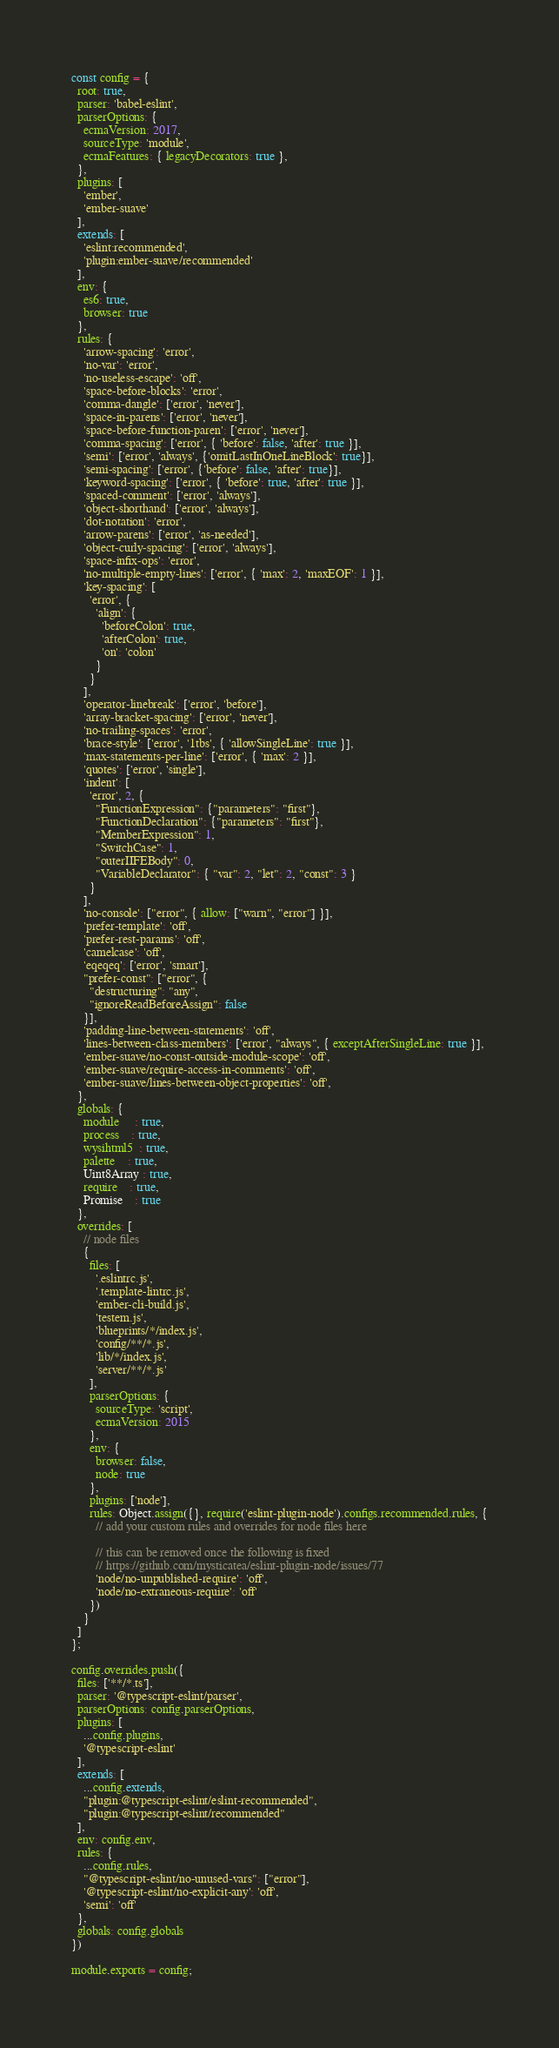<code> <loc_0><loc_0><loc_500><loc_500><_JavaScript_>const config = {
  root: true,
  parser: 'babel-eslint',
  parserOptions: {
    ecmaVersion: 2017,
    sourceType: 'module',
    ecmaFeatures: { legacyDecorators: true },
  },
  plugins: [
    'ember',
    'ember-suave'
  ],
  extends: [
    'eslint:recommended',
    'plugin:ember-suave/recommended'
  ],
  env: {
    es6: true,
    browser: true
  },
  rules: {
    'arrow-spacing': 'error',
    'no-var': 'error',
    'no-useless-escape': 'off',
    'space-before-blocks': 'error',
    'comma-dangle': ['error', 'never'],
    'space-in-parens': ['error', 'never'],
    'space-before-function-paren': ['error', 'never'],
    'comma-spacing': ['error', { 'before': false, 'after': true }],
    'semi': ['error', 'always', {'omitLastInOneLineBlock': true}],
    'semi-spacing': ['error', {'before': false, 'after': true}],
    'keyword-spacing': ['error', { 'before': true, 'after': true }],
    'spaced-comment': ['error', 'always'],
    'object-shorthand': ['error', 'always'],
    'dot-notation': 'error',
    'arrow-parens': ['error', 'as-needed'],
    'object-curly-spacing': ['error', 'always'],
    'space-infix-ops': 'error',
    'no-multiple-empty-lines': ['error', { 'max': 2, 'maxEOF': 1 }],
    'key-spacing': [
      'error', {
        'align': {
          'beforeColon': true,
          'afterColon': true,
          'on': 'colon'
        }
      }
    ],
    'operator-linebreak': ['error', 'before'],
    'array-bracket-spacing': ['error', 'never'],
    'no-trailing-spaces': 'error',
    'brace-style': ['error', '1tbs', { 'allowSingleLine': true }],
    'max-statements-per-line': ['error', { 'max': 2 }],
    'quotes': ['error', 'single'],
    'indent': [
      'error', 2, {
        "FunctionExpression": {"parameters": "first"},
        "FunctionDeclaration": {"parameters": "first"},
        "MemberExpression": 1,
        "SwitchCase": 1,
        "outerIIFEBody": 0,
        "VariableDeclarator": { "var": 2, "let": 2, "const": 3 }
      }
    ],
    'no-console': ["error", { allow: ["warn", "error"] }],
    'prefer-template': 'off',
    'prefer-rest-params': 'off',
    'camelcase': 'off',
    'eqeqeq': ['error', 'smart'],
    "prefer-const": ["error", {
      "destructuring": "any",
      "ignoreReadBeforeAssign": false
    }],
    'padding-line-between-statements': 'off',
    'lines-between-class-members': ['error', "always", { exceptAfterSingleLine: true }],
    'ember-suave/no-const-outside-module-scope': 'off',
    'ember-suave/require-access-in-comments': 'off',
    'ember-suave/lines-between-object-properties': 'off',
  },
  globals: {
    module     : true,
    process    : true,
    wysihtml5  : true,
    palette    : true,
    Uint8Array : true,
    require    : true,
    Promise    : true
  },
  overrides: [
    // node files
    {
      files: [
        '.eslintrc.js',
        '.template-lintrc.js',
        'ember-cli-build.js',
        'testem.js',
        'blueprints/*/index.js',
        'config/**/*.js',
        'lib/*/index.js',
        'server/**/*.js'
      ],
      parserOptions: {
        sourceType: 'script',
        ecmaVersion: 2015
      },
      env: {
        browser: false,
        node: true
      },
      plugins: ['node'],
      rules: Object.assign({}, require('eslint-plugin-node').configs.recommended.rules, {
        // add your custom rules and overrides for node files here

        // this can be removed once the following is fixed
        // https://github.com/mysticatea/eslint-plugin-node/issues/77
        'node/no-unpublished-require': 'off',
        'node/no-extraneous-require': 'off'
      })
    }
  ]
};

config.overrides.push({
  files: ['**/*.ts'],
  parser: '@typescript-eslint/parser',
  parserOptions: config.parserOptions,
  plugins: [
    ...config.plugins,
    '@typescript-eslint'
  ],
  extends: [
    ...config.extends,
    "plugin:@typescript-eslint/eslint-recommended",
    "plugin:@typescript-eslint/recommended"
  ],
  env: config.env,
  rules: {
    ...config.rules,
    "@typescript-eslint/no-unused-vars": ["error"],
    '@typescript-eslint/no-explicit-any': 'off',
    'semi': 'off'
  },
  globals: config.globals
})

module.exports = config;
</code> 